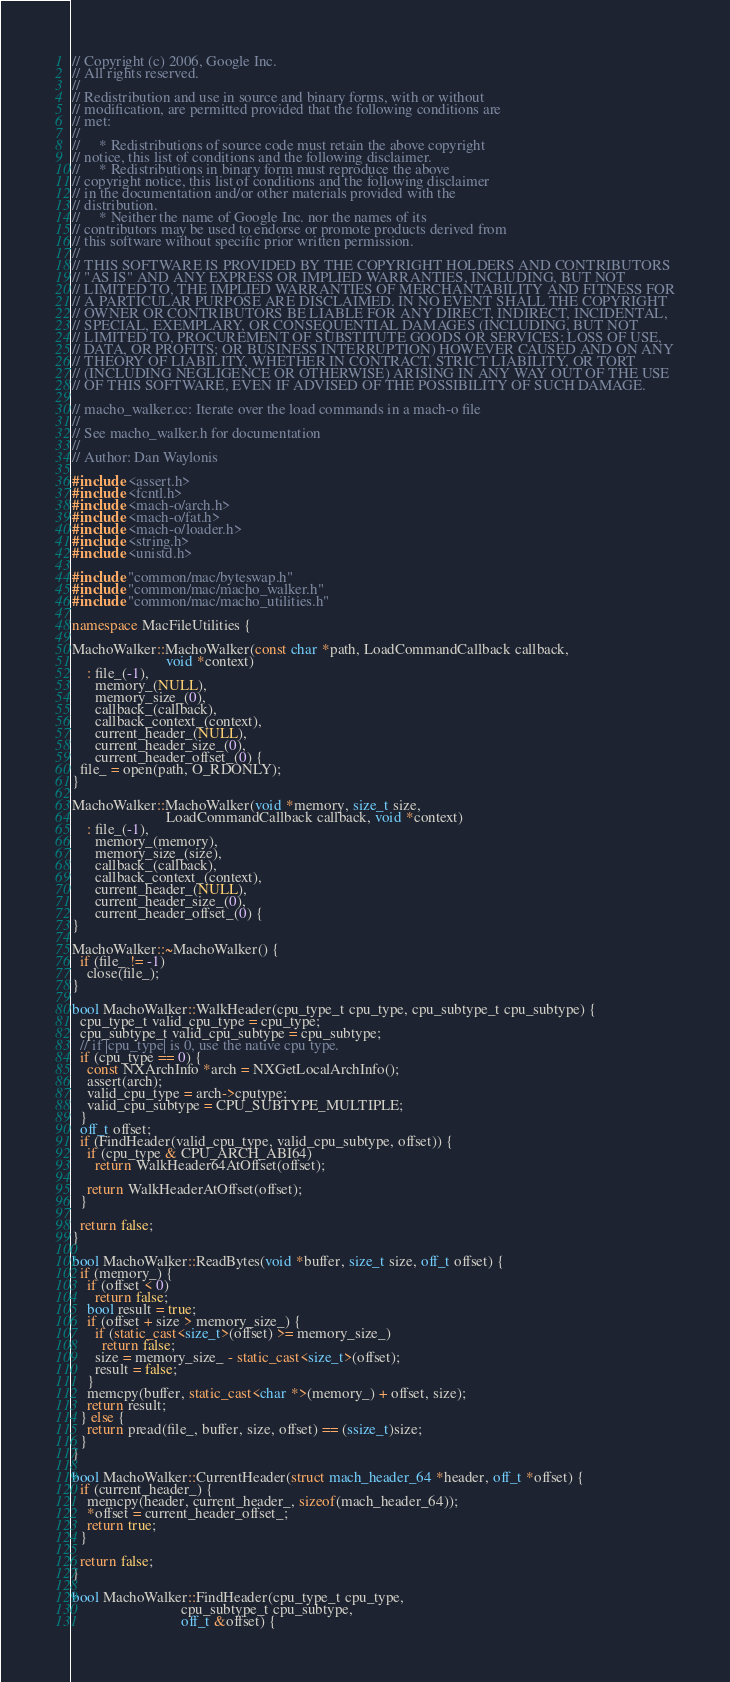<code> <loc_0><loc_0><loc_500><loc_500><_C++_>// Copyright (c) 2006, Google Inc.
// All rights reserved.
//
// Redistribution and use in source and binary forms, with or without
// modification, are permitted provided that the following conditions are
// met:
//
//     * Redistributions of source code must retain the above copyright
// notice, this list of conditions and the following disclaimer.
//     * Redistributions in binary form must reproduce the above
// copyright notice, this list of conditions and the following disclaimer
// in the documentation and/or other materials provided with the
// distribution.
//     * Neither the name of Google Inc. nor the names of its
// contributors may be used to endorse or promote products derived from
// this software without specific prior written permission.
//
// THIS SOFTWARE IS PROVIDED BY THE COPYRIGHT HOLDERS AND CONTRIBUTORS
// "AS IS" AND ANY EXPRESS OR IMPLIED WARRANTIES, INCLUDING, BUT NOT
// LIMITED TO, THE IMPLIED WARRANTIES OF MERCHANTABILITY AND FITNESS FOR
// A PARTICULAR PURPOSE ARE DISCLAIMED. IN NO EVENT SHALL THE COPYRIGHT
// OWNER OR CONTRIBUTORS BE LIABLE FOR ANY DIRECT, INDIRECT, INCIDENTAL,
// SPECIAL, EXEMPLARY, OR CONSEQUENTIAL DAMAGES (INCLUDING, BUT NOT
// LIMITED TO, PROCUREMENT OF SUBSTITUTE GOODS OR SERVICES; LOSS OF USE,
// DATA, OR PROFITS; OR BUSINESS INTERRUPTION) HOWEVER CAUSED AND ON ANY
// THEORY OF LIABILITY, WHETHER IN CONTRACT, STRICT LIABILITY, OR TORT
// (INCLUDING NEGLIGENCE OR OTHERWISE) ARISING IN ANY WAY OUT OF THE USE
// OF THIS SOFTWARE, EVEN IF ADVISED OF THE POSSIBILITY OF SUCH DAMAGE.

// macho_walker.cc: Iterate over the load commands in a mach-o file
//
// See macho_walker.h for documentation
//
// Author: Dan Waylonis

#include <assert.h>
#include <fcntl.h>
#include <mach-o/arch.h>
#include <mach-o/fat.h>
#include <mach-o/loader.h>
#include <string.h>
#include <unistd.h>

#include "common/mac/byteswap.h"
#include "common/mac/macho_walker.h"
#include "common/mac/macho_utilities.h"

namespace MacFileUtilities {

MachoWalker::MachoWalker(const char *path, LoadCommandCallback callback,
                         void *context)
    : file_(-1),
      memory_(NULL),
      memory_size_(0),
      callback_(callback),
      callback_context_(context),
      current_header_(NULL),
      current_header_size_(0),
      current_header_offset_(0) {
  file_ = open(path, O_RDONLY);
}

MachoWalker::MachoWalker(void *memory, size_t size,
                         LoadCommandCallback callback, void *context)
    : file_(-1),
      memory_(memory),
      memory_size_(size),
      callback_(callback),
      callback_context_(context),
      current_header_(NULL),
      current_header_size_(0),
      current_header_offset_(0) {
}

MachoWalker::~MachoWalker() {
  if (file_ != -1)
    close(file_);
}

bool MachoWalker::WalkHeader(cpu_type_t cpu_type, cpu_subtype_t cpu_subtype) {
  cpu_type_t valid_cpu_type = cpu_type;
  cpu_subtype_t valid_cpu_subtype = cpu_subtype;
  // if |cpu_type| is 0, use the native cpu type.
  if (cpu_type == 0) {
    const NXArchInfo *arch = NXGetLocalArchInfo();
    assert(arch);
    valid_cpu_type = arch->cputype;
    valid_cpu_subtype = CPU_SUBTYPE_MULTIPLE;
  }
  off_t offset;
  if (FindHeader(valid_cpu_type, valid_cpu_subtype, offset)) {
    if (cpu_type & CPU_ARCH_ABI64)
      return WalkHeader64AtOffset(offset);

    return WalkHeaderAtOffset(offset);
  }

  return false;
}

bool MachoWalker::ReadBytes(void *buffer, size_t size, off_t offset) {
  if (memory_) {
    if (offset < 0)
      return false;
    bool result = true;
    if (offset + size > memory_size_) {
      if (static_cast<size_t>(offset) >= memory_size_)
        return false;
      size = memory_size_ - static_cast<size_t>(offset);
      result = false;
    }
    memcpy(buffer, static_cast<char *>(memory_) + offset, size);
    return result;
  } else {
    return pread(file_, buffer, size, offset) == (ssize_t)size;
  }
}

bool MachoWalker::CurrentHeader(struct mach_header_64 *header, off_t *offset) {
  if (current_header_) {
    memcpy(header, current_header_, sizeof(mach_header_64));
    *offset = current_header_offset_;
    return true;
  }

  return false;
}

bool MachoWalker::FindHeader(cpu_type_t cpu_type,
                             cpu_subtype_t cpu_subtype,
                             off_t &offset) {</code> 